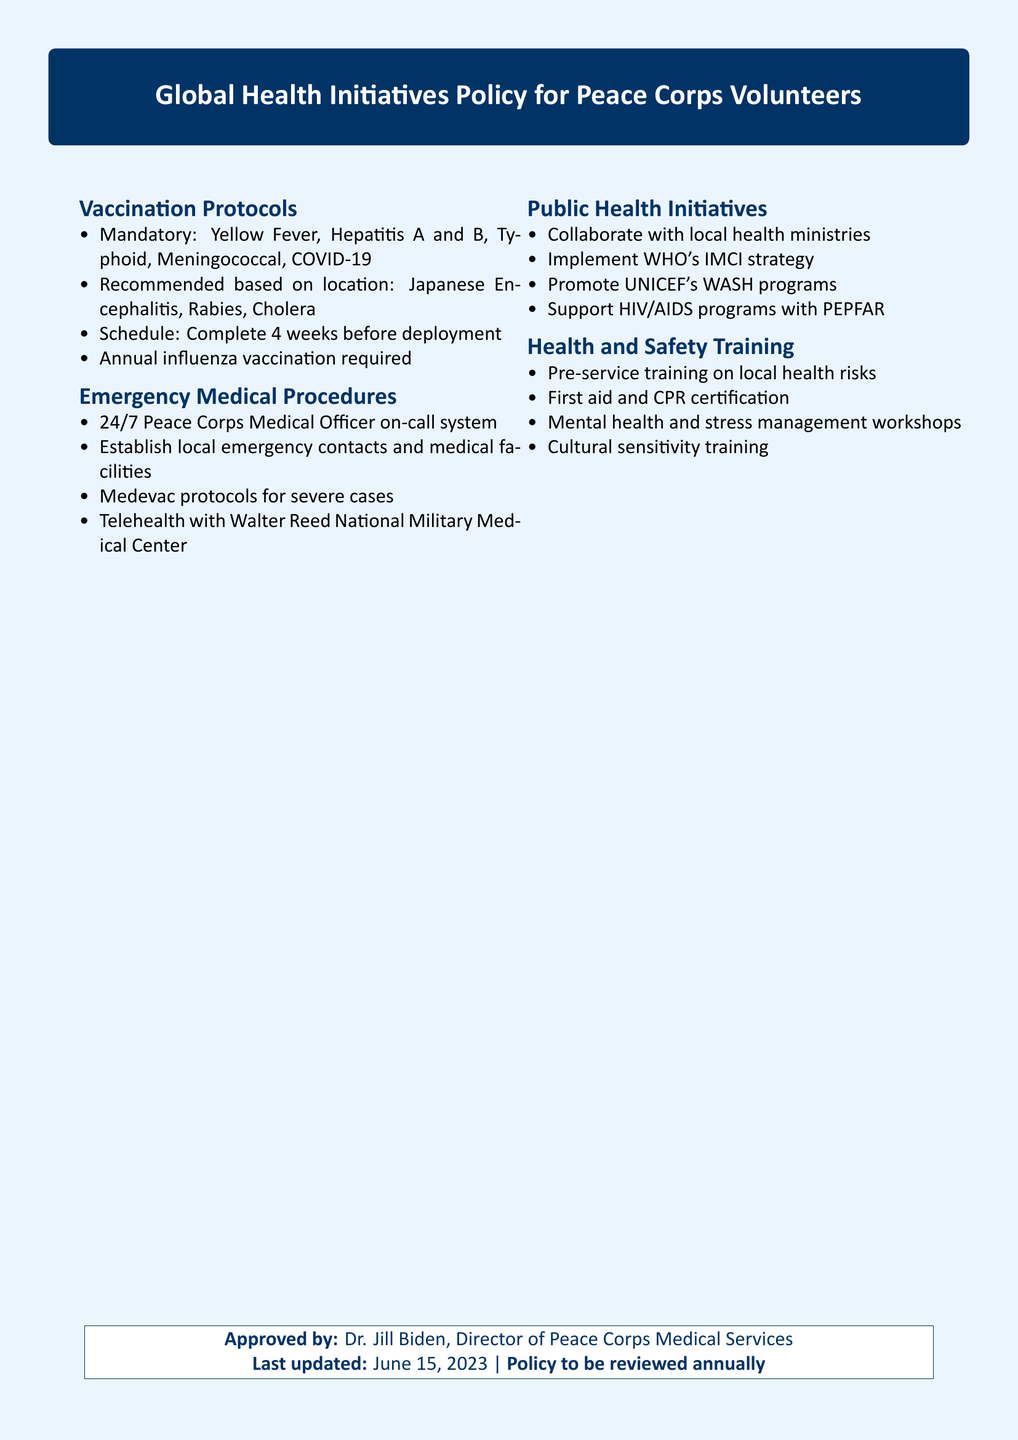What vaccinations are mandatory? The document lists mandatory vaccinations that include Yellow Fever, Hepatitis A and B, Typhoid, Meningococcal, and COVID-19.
Answer: Yellow Fever, Hepatitis A and B, Typhoid, Meningococcal, COVID-19 What is the schedule for vaccinations? According to the document, the vaccinations should be completed four weeks before deployment.
Answer: 4 weeks before deployment Who is on-call for medical emergencies? The document states that there is a 24/7 Peace Corps Medical Officer on-call system for emergencies.
Answer: 24/7 Peace Corps Medical Officer What public health programs are supported? The document mentions supporting HIV/AIDS programs with PEPFAR as one of the public health initiatives.
Answer: HIV/AIDS programs with PEPFAR When was the policy last updated? The document notes that the policy was last updated on June 15, 2023.
Answer: June 15, 2023 Which organization’s programs does the policy promote? The document promotes UNICEF's WASH programs as part of its public health initiatives.
Answer: UNICEF's WASH programs What type of training is provided before service? The document specifies that pre-service training covers local health risks.
Answer: Local health risks What must be done in severe medical cases? According to the document, medevac protocols are established for severe medical cases.
Answer: Medevac protocols 